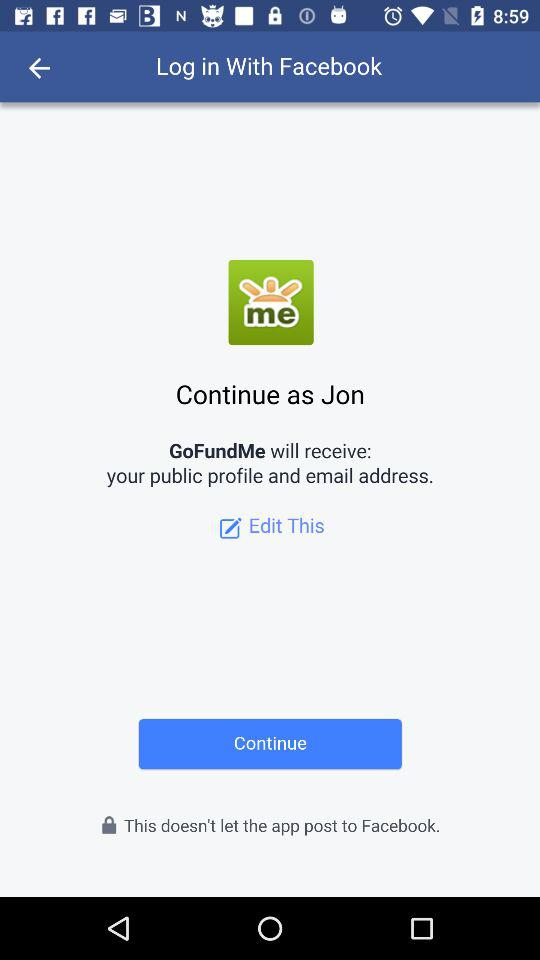What is the login name? The login name is Jon. 